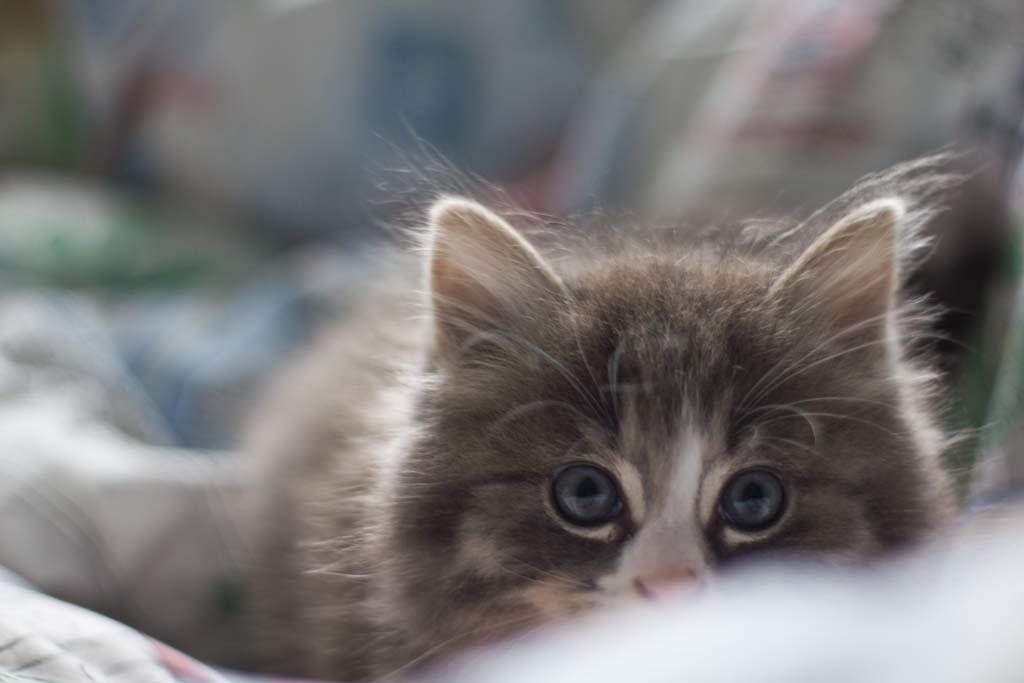Please provide a concise description of this image. Here I can see a cat is looking at the picture. Beside this cat there are few clothes. The background is blurred. 